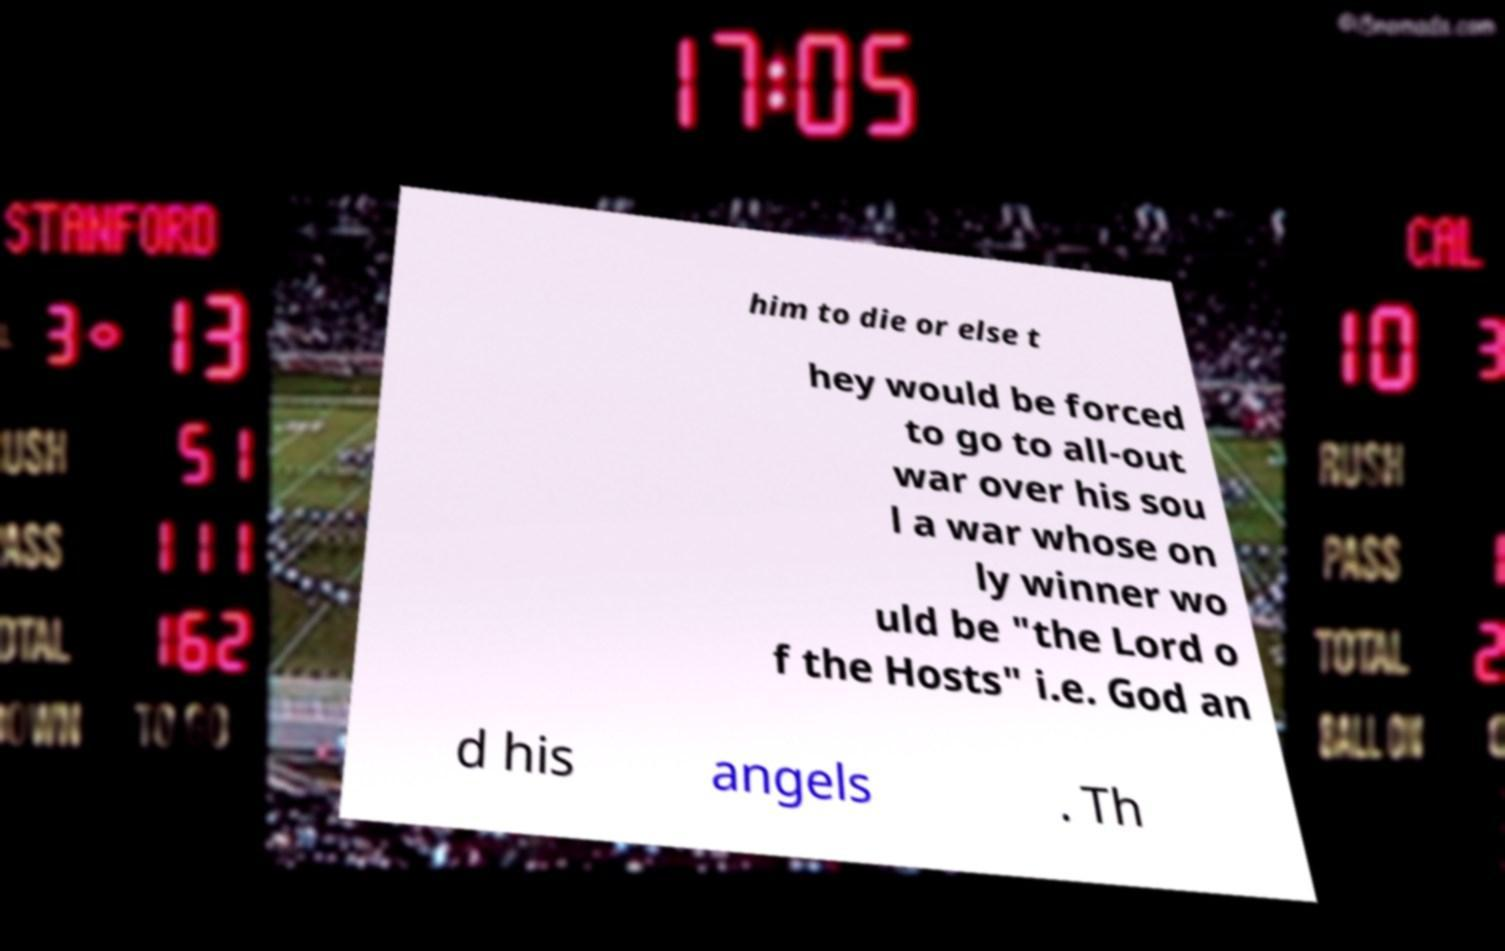For documentation purposes, I need the text within this image transcribed. Could you provide that? him to die or else t hey would be forced to go to all-out war over his sou l a war whose on ly winner wo uld be "the Lord o f the Hosts" i.e. God an d his angels . Th 